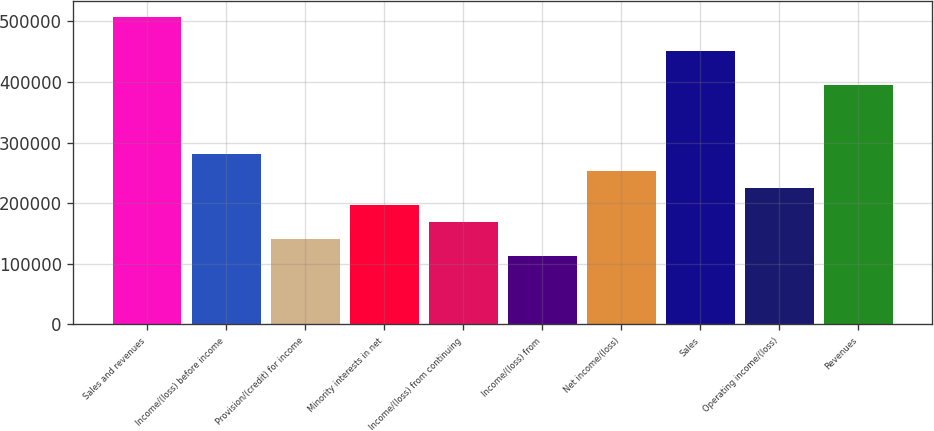Convert chart. <chart><loc_0><loc_0><loc_500><loc_500><bar_chart><fcel>Sales and revenues<fcel>Income/(loss) before income<fcel>Provision/(credit) for income<fcel>Minority interests in net<fcel>Income/(loss) from continuing<fcel>Income/(loss) from<fcel>Net income/(loss)<fcel>Sales<fcel>Operating income/(loss)<fcel>Revenues<nl><fcel>507535<fcel>281964<fcel>140982<fcel>197375<fcel>169178<fcel>112786<fcel>253768<fcel>451142<fcel>225571<fcel>394750<nl></chart> 